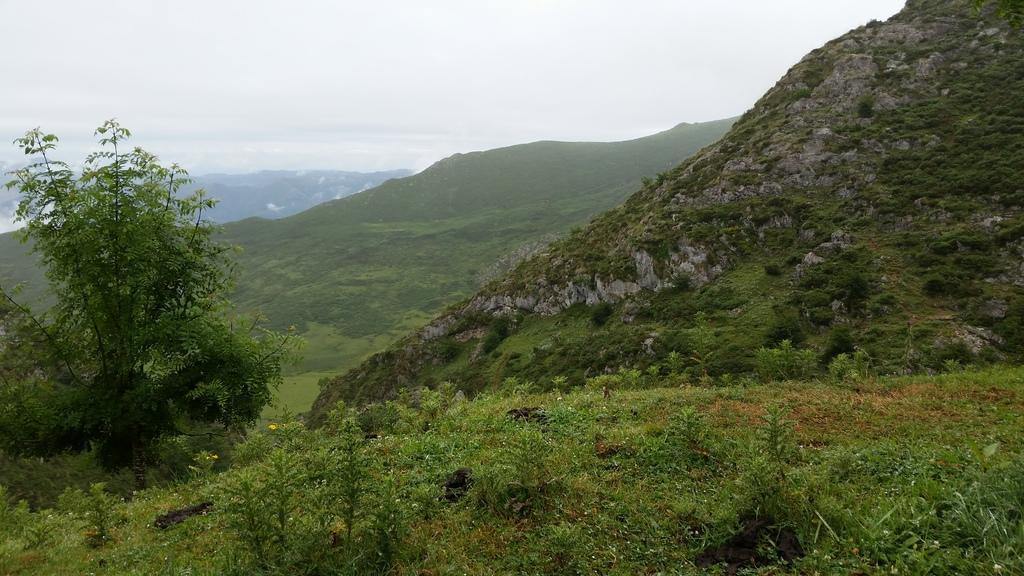How would you summarize this image in a sentence or two? There are plants and trees. In the back there are hills and sky. 